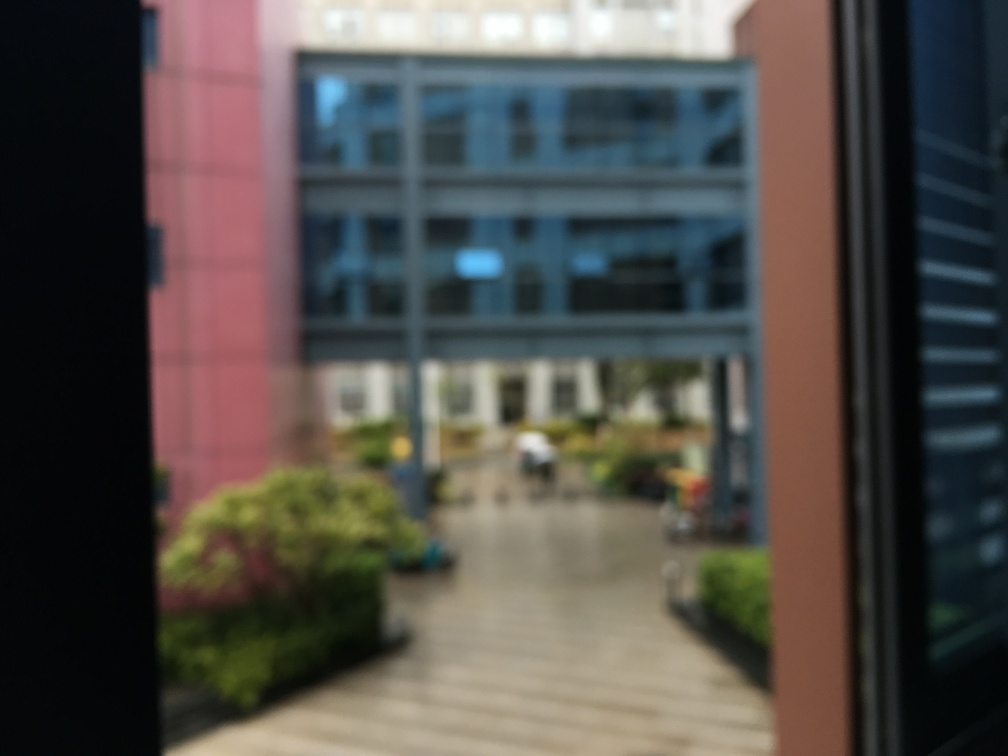Are there any quality issues with this image? Yes, the image is out of focus, which diminishes the sharpness and clarity of the details. This blurring could be due to camera movement or an incorrect focus setting when the photo was taken. 